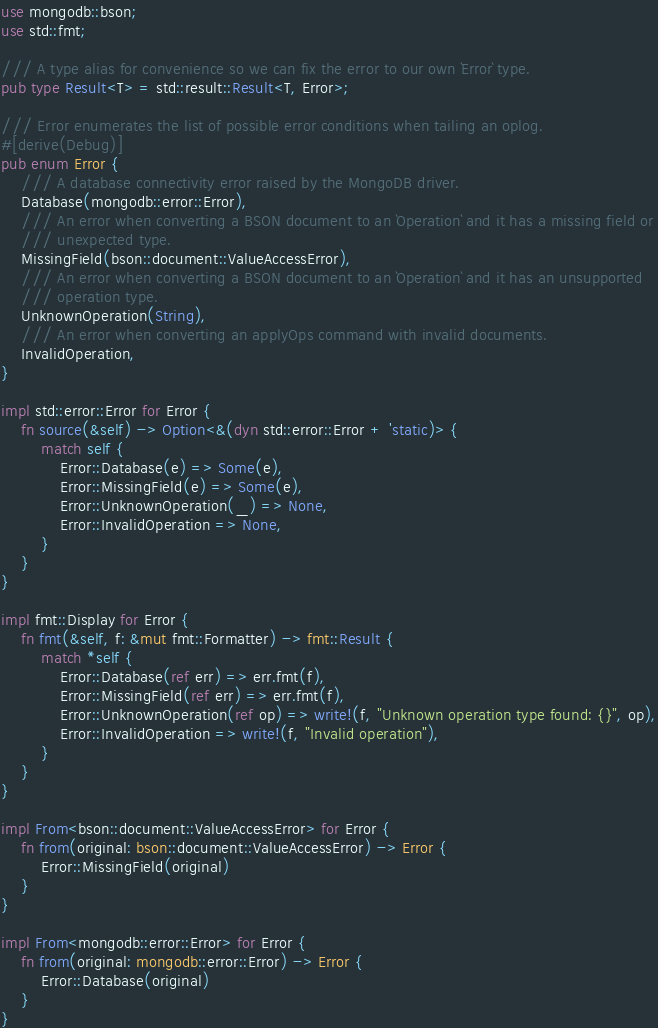<code> <loc_0><loc_0><loc_500><loc_500><_Rust_>use mongodb::bson;
use std::fmt;

/// A type alias for convenience so we can fix the error to our own `Error` type.
pub type Result<T> = std::result::Result<T, Error>;

/// Error enumerates the list of possible error conditions when tailing an oplog.
#[derive(Debug)]
pub enum Error {
    /// A database connectivity error raised by the MongoDB driver.
    Database(mongodb::error::Error),
    /// An error when converting a BSON document to an `Operation` and it has a missing field or
    /// unexpected type.
    MissingField(bson::document::ValueAccessError),
    /// An error when converting a BSON document to an `Operation` and it has an unsupported
    /// operation type.
    UnknownOperation(String),
    /// An error when converting an applyOps command with invalid documents.
    InvalidOperation,
}

impl std::error::Error for Error {
    fn source(&self) -> Option<&(dyn std::error::Error + 'static)> {
        match self {
            Error::Database(e) => Some(e),
            Error::MissingField(e) => Some(e),
            Error::UnknownOperation(_) => None,
            Error::InvalidOperation => None,
        }
    }
}

impl fmt::Display for Error {
    fn fmt(&self, f: &mut fmt::Formatter) -> fmt::Result {
        match *self {
            Error::Database(ref err) => err.fmt(f),
            Error::MissingField(ref err) => err.fmt(f),
            Error::UnknownOperation(ref op) => write!(f, "Unknown operation type found: {}", op),
            Error::InvalidOperation => write!(f, "Invalid operation"),
        }
    }
}

impl From<bson::document::ValueAccessError> for Error {
    fn from(original: bson::document::ValueAccessError) -> Error {
        Error::MissingField(original)
    }
}

impl From<mongodb::error::Error> for Error {
    fn from(original: mongodb::error::Error) -> Error {
        Error::Database(original)
    }
}
</code> 